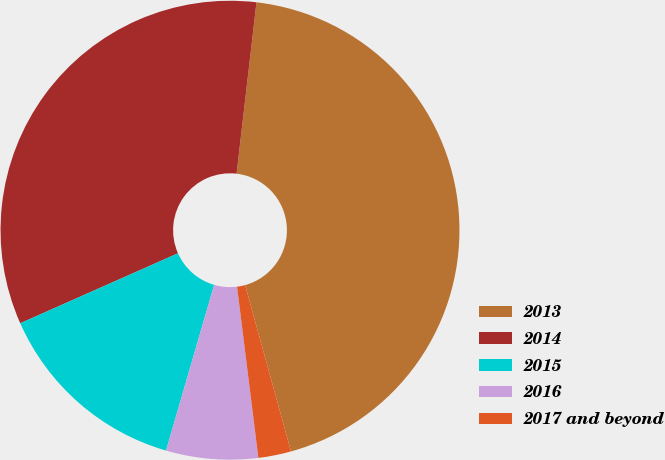<chart> <loc_0><loc_0><loc_500><loc_500><pie_chart><fcel>2013<fcel>2014<fcel>2015<fcel>2016<fcel>2017 and beyond<nl><fcel>43.88%<fcel>33.49%<fcel>13.86%<fcel>6.47%<fcel>2.31%<nl></chart> 